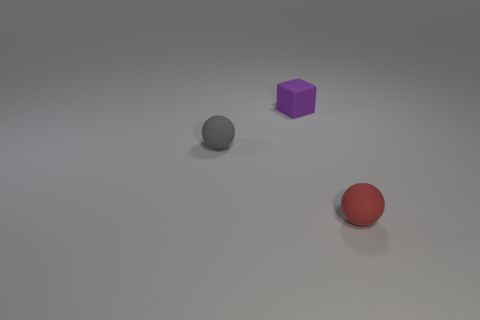Can you tell me the positions of the objects relative to each other? Certainly! In the scene, the red sphere is positioned at the front, the purple cube is set slightly behind and to the left of the red sphere, and the grey sphere is positioned furthest away, to the right of the purple cube. 